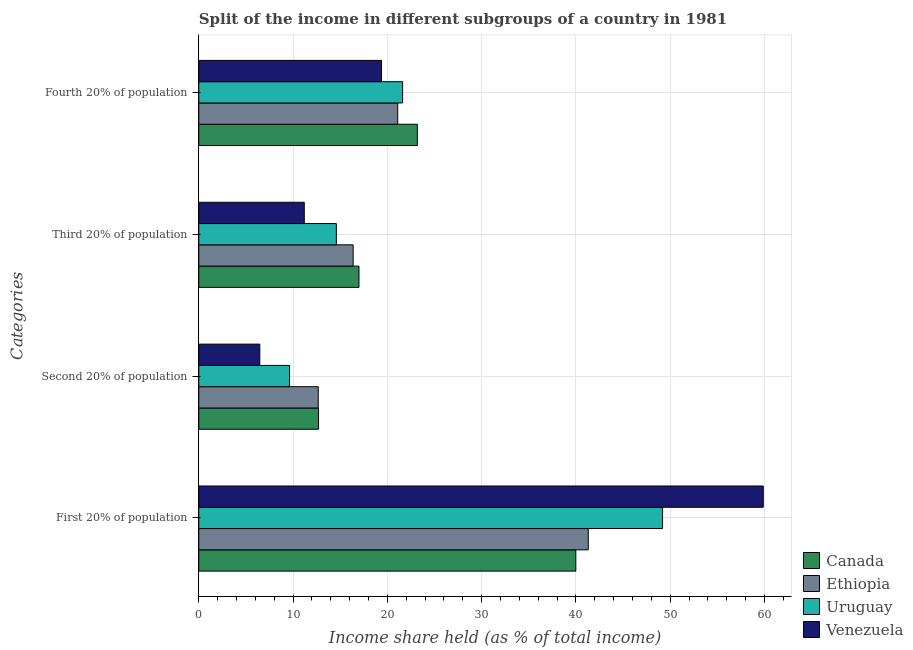How many groups of bars are there?
Ensure brevity in your answer.  4. How many bars are there on the 1st tick from the top?
Keep it short and to the point. 4. How many bars are there on the 2nd tick from the bottom?
Make the answer very short. 4. What is the label of the 3rd group of bars from the top?
Offer a very short reply. Second 20% of population. What is the share of the income held by second 20% of the population in Canada?
Provide a short and direct response. 12.7. Across all countries, what is the maximum share of the income held by third 20% of the population?
Your answer should be compact. 16.99. Across all countries, what is the minimum share of the income held by second 20% of the population?
Make the answer very short. 6.47. In which country was the share of the income held by third 20% of the population minimum?
Your response must be concise. Venezuela. What is the total share of the income held by second 20% of the population in the graph?
Ensure brevity in your answer.  41.47. What is the difference between the share of the income held by fourth 20% of the population in Ethiopia and that in Venezuela?
Provide a short and direct response. 1.72. What is the difference between the share of the income held by third 20% of the population in Uruguay and the share of the income held by first 20% of the population in Venezuela?
Keep it short and to the point. -45.28. What is the average share of the income held by fourth 20% of the population per country?
Give a very brief answer. 21.32. What is the difference between the share of the income held by first 20% of the population and share of the income held by second 20% of the population in Uruguay?
Make the answer very short. 39.56. What is the ratio of the share of the income held by third 20% of the population in Ethiopia to that in Canada?
Make the answer very short. 0.96. Is the share of the income held by first 20% of the population in Canada less than that in Venezuela?
Your response must be concise. Yes. Is the difference between the share of the income held by fourth 20% of the population in Venezuela and Uruguay greater than the difference between the share of the income held by second 20% of the population in Venezuela and Uruguay?
Provide a short and direct response. Yes. What is the difference between the highest and the second highest share of the income held by second 20% of the population?
Provide a succinct answer. 0.03. What is the difference between the highest and the lowest share of the income held by third 20% of the population?
Make the answer very short. 5.8. In how many countries, is the share of the income held by fourth 20% of the population greater than the average share of the income held by fourth 20% of the population taken over all countries?
Your answer should be very brief. 2. Is the sum of the share of the income held by fourth 20% of the population in Venezuela and Canada greater than the maximum share of the income held by first 20% of the population across all countries?
Keep it short and to the point. No. Is it the case that in every country, the sum of the share of the income held by third 20% of the population and share of the income held by second 20% of the population is greater than the sum of share of the income held by first 20% of the population and share of the income held by fourth 20% of the population?
Offer a terse response. Yes. What does the 2nd bar from the top in Second 20% of population represents?
Provide a succinct answer. Uruguay. What does the 3rd bar from the bottom in Fourth 20% of population represents?
Your response must be concise. Uruguay. How many bars are there?
Make the answer very short. 16. Are the values on the major ticks of X-axis written in scientific E-notation?
Offer a very short reply. No. Does the graph contain any zero values?
Make the answer very short. No. Does the graph contain grids?
Your answer should be compact. Yes. Where does the legend appear in the graph?
Keep it short and to the point. Bottom right. How many legend labels are there?
Your answer should be compact. 4. What is the title of the graph?
Provide a short and direct response. Split of the income in different subgroups of a country in 1981. Does "Turkmenistan" appear as one of the legend labels in the graph?
Give a very brief answer. No. What is the label or title of the X-axis?
Provide a short and direct response. Income share held (as % of total income). What is the label or title of the Y-axis?
Make the answer very short. Categories. What is the Income share held (as % of total income) of Canada in First 20% of population?
Make the answer very short. 39.99. What is the Income share held (as % of total income) in Ethiopia in First 20% of population?
Provide a short and direct response. 41.31. What is the Income share held (as % of total income) in Uruguay in First 20% of population?
Your response must be concise. 49.19. What is the Income share held (as % of total income) of Venezuela in First 20% of population?
Give a very brief answer. 59.87. What is the Income share held (as % of total income) in Canada in Second 20% of population?
Offer a very short reply. 12.7. What is the Income share held (as % of total income) in Ethiopia in Second 20% of population?
Offer a very short reply. 12.67. What is the Income share held (as % of total income) of Uruguay in Second 20% of population?
Provide a short and direct response. 9.63. What is the Income share held (as % of total income) in Venezuela in Second 20% of population?
Offer a terse response. 6.47. What is the Income share held (as % of total income) in Canada in Third 20% of population?
Keep it short and to the point. 16.99. What is the Income share held (as % of total income) of Ethiopia in Third 20% of population?
Offer a terse response. 16.37. What is the Income share held (as % of total income) of Uruguay in Third 20% of population?
Provide a short and direct response. 14.59. What is the Income share held (as % of total income) of Venezuela in Third 20% of population?
Your answer should be very brief. 11.19. What is the Income share held (as % of total income) of Canada in Fourth 20% of population?
Keep it short and to the point. 23.18. What is the Income share held (as % of total income) of Ethiopia in Fourth 20% of population?
Provide a succinct answer. 21.1. What is the Income share held (as % of total income) in Uruguay in Fourth 20% of population?
Keep it short and to the point. 21.62. What is the Income share held (as % of total income) of Venezuela in Fourth 20% of population?
Provide a succinct answer. 19.38. Across all Categories, what is the maximum Income share held (as % of total income) of Canada?
Give a very brief answer. 39.99. Across all Categories, what is the maximum Income share held (as % of total income) in Ethiopia?
Provide a succinct answer. 41.31. Across all Categories, what is the maximum Income share held (as % of total income) of Uruguay?
Provide a succinct answer. 49.19. Across all Categories, what is the maximum Income share held (as % of total income) in Venezuela?
Your answer should be compact. 59.87. Across all Categories, what is the minimum Income share held (as % of total income) in Ethiopia?
Your answer should be compact. 12.67. Across all Categories, what is the minimum Income share held (as % of total income) of Uruguay?
Your answer should be very brief. 9.63. Across all Categories, what is the minimum Income share held (as % of total income) of Venezuela?
Provide a short and direct response. 6.47. What is the total Income share held (as % of total income) in Canada in the graph?
Provide a succinct answer. 92.86. What is the total Income share held (as % of total income) of Ethiopia in the graph?
Your answer should be very brief. 91.45. What is the total Income share held (as % of total income) of Uruguay in the graph?
Provide a succinct answer. 95.03. What is the total Income share held (as % of total income) in Venezuela in the graph?
Your answer should be compact. 96.91. What is the difference between the Income share held (as % of total income) in Canada in First 20% of population and that in Second 20% of population?
Your response must be concise. 27.29. What is the difference between the Income share held (as % of total income) in Ethiopia in First 20% of population and that in Second 20% of population?
Provide a short and direct response. 28.64. What is the difference between the Income share held (as % of total income) of Uruguay in First 20% of population and that in Second 20% of population?
Provide a succinct answer. 39.56. What is the difference between the Income share held (as % of total income) of Venezuela in First 20% of population and that in Second 20% of population?
Give a very brief answer. 53.4. What is the difference between the Income share held (as % of total income) in Canada in First 20% of population and that in Third 20% of population?
Provide a succinct answer. 23. What is the difference between the Income share held (as % of total income) in Ethiopia in First 20% of population and that in Third 20% of population?
Provide a succinct answer. 24.94. What is the difference between the Income share held (as % of total income) in Uruguay in First 20% of population and that in Third 20% of population?
Your answer should be very brief. 34.6. What is the difference between the Income share held (as % of total income) of Venezuela in First 20% of population and that in Third 20% of population?
Your response must be concise. 48.68. What is the difference between the Income share held (as % of total income) of Canada in First 20% of population and that in Fourth 20% of population?
Your response must be concise. 16.81. What is the difference between the Income share held (as % of total income) of Ethiopia in First 20% of population and that in Fourth 20% of population?
Offer a terse response. 20.21. What is the difference between the Income share held (as % of total income) in Uruguay in First 20% of population and that in Fourth 20% of population?
Provide a succinct answer. 27.57. What is the difference between the Income share held (as % of total income) in Venezuela in First 20% of population and that in Fourth 20% of population?
Provide a succinct answer. 40.49. What is the difference between the Income share held (as % of total income) in Canada in Second 20% of population and that in Third 20% of population?
Your answer should be very brief. -4.29. What is the difference between the Income share held (as % of total income) in Uruguay in Second 20% of population and that in Third 20% of population?
Offer a terse response. -4.96. What is the difference between the Income share held (as % of total income) in Venezuela in Second 20% of population and that in Third 20% of population?
Your response must be concise. -4.72. What is the difference between the Income share held (as % of total income) of Canada in Second 20% of population and that in Fourth 20% of population?
Give a very brief answer. -10.48. What is the difference between the Income share held (as % of total income) in Ethiopia in Second 20% of population and that in Fourth 20% of population?
Provide a succinct answer. -8.43. What is the difference between the Income share held (as % of total income) in Uruguay in Second 20% of population and that in Fourth 20% of population?
Make the answer very short. -11.99. What is the difference between the Income share held (as % of total income) of Venezuela in Second 20% of population and that in Fourth 20% of population?
Give a very brief answer. -12.91. What is the difference between the Income share held (as % of total income) of Canada in Third 20% of population and that in Fourth 20% of population?
Provide a short and direct response. -6.19. What is the difference between the Income share held (as % of total income) in Ethiopia in Third 20% of population and that in Fourth 20% of population?
Make the answer very short. -4.73. What is the difference between the Income share held (as % of total income) of Uruguay in Third 20% of population and that in Fourth 20% of population?
Offer a very short reply. -7.03. What is the difference between the Income share held (as % of total income) in Venezuela in Third 20% of population and that in Fourth 20% of population?
Your answer should be compact. -8.19. What is the difference between the Income share held (as % of total income) in Canada in First 20% of population and the Income share held (as % of total income) in Ethiopia in Second 20% of population?
Give a very brief answer. 27.32. What is the difference between the Income share held (as % of total income) in Canada in First 20% of population and the Income share held (as % of total income) in Uruguay in Second 20% of population?
Make the answer very short. 30.36. What is the difference between the Income share held (as % of total income) of Canada in First 20% of population and the Income share held (as % of total income) of Venezuela in Second 20% of population?
Offer a very short reply. 33.52. What is the difference between the Income share held (as % of total income) of Ethiopia in First 20% of population and the Income share held (as % of total income) of Uruguay in Second 20% of population?
Offer a very short reply. 31.68. What is the difference between the Income share held (as % of total income) of Ethiopia in First 20% of population and the Income share held (as % of total income) of Venezuela in Second 20% of population?
Offer a very short reply. 34.84. What is the difference between the Income share held (as % of total income) in Uruguay in First 20% of population and the Income share held (as % of total income) in Venezuela in Second 20% of population?
Your response must be concise. 42.72. What is the difference between the Income share held (as % of total income) of Canada in First 20% of population and the Income share held (as % of total income) of Ethiopia in Third 20% of population?
Your response must be concise. 23.62. What is the difference between the Income share held (as % of total income) of Canada in First 20% of population and the Income share held (as % of total income) of Uruguay in Third 20% of population?
Offer a terse response. 25.4. What is the difference between the Income share held (as % of total income) of Canada in First 20% of population and the Income share held (as % of total income) of Venezuela in Third 20% of population?
Offer a very short reply. 28.8. What is the difference between the Income share held (as % of total income) of Ethiopia in First 20% of population and the Income share held (as % of total income) of Uruguay in Third 20% of population?
Provide a short and direct response. 26.72. What is the difference between the Income share held (as % of total income) in Ethiopia in First 20% of population and the Income share held (as % of total income) in Venezuela in Third 20% of population?
Your answer should be very brief. 30.12. What is the difference between the Income share held (as % of total income) of Uruguay in First 20% of population and the Income share held (as % of total income) of Venezuela in Third 20% of population?
Your response must be concise. 38. What is the difference between the Income share held (as % of total income) in Canada in First 20% of population and the Income share held (as % of total income) in Ethiopia in Fourth 20% of population?
Keep it short and to the point. 18.89. What is the difference between the Income share held (as % of total income) of Canada in First 20% of population and the Income share held (as % of total income) of Uruguay in Fourth 20% of population?
Your answer should be very brief. 18.37. What is the difference between the Income share held (as % of total income) in Canada in First 20% of population and the Income share held (as % of total income) in Venezuela in Fourth 20% of population?
Provide a short and direct response. 20.61. What is the difference between the Income share held (as % of total income) of Ethiopia in First 20% of population and the Income share held (as % of total income) of Uruguay in Fourth 20% of population?
Provide a short and direct response. 19.69. What is the difference between the Income share held (as % of total income) in Ethiopia in First 20% of population and the Income share held (as % of total income) in Venezuela in Fourth 20% of population?
Provide a succinct answer. 21.93. What is the difference between the Income share held (as % of total income) of Uruguay in First 20% of population and the Income share held (as % of total income) of Venezuela in Fourth 20% of population?
Provide a succinct answer. 29.81. What is the difference between the Income share held (as % of total income) of Canada in Second 20% of population and the Income share held (as % of total income) of Ethiopia in Third 20% of population?
Offer a very short reply. -3.67. What is the difference between the Income share held (as % of total income) of Canada in Second 20% of population and the Income share held (as % of total income) of Uruguay in Third 20% of population?
Keep it short and to the point. -1.89. What is the difference between the Income share held (as % of total income) of Canada in Second 20% of population and the Income share held (as % of total income) of Venezuela in Third 20% of population?
Your answer should be compact. 1.51. What is the difference between the Income share held (as % of total income) in Ethiopia in Second 20% of population and the Income share held (as % of total income) in Uruguay in Third 20% of population?
Offer a terse response. -1.92. What is the difference between the Income share held (as % of total income) of Ethiopia in Second 20% of population and the Income share held (as % of total income) of Venezuela in Third 20% of population?
Provide a short and direct response. 1.48. What is the difference between the Income share held (as % of total income) of Uruguay in Second 20% of population and the Income share held (as % of total income) of Venezuela in Third 20% of population?
Your answer should be very brief. -1.56. What is the difference between the Income share held (as % of total income) in Canada in Second 20% of population and the Income share held (as % of total income) in Ethiopia in Fourth 20% of population?
Offer a terse response. -8.4. What is the difference between the Income share held (as % of total income) of Canada in Second 20% of population and the Income share held (as % of total income) of Uruguay in Fourth 20% of population?
Your response must be concise. -8.92. What is the difference between the Income share held (as % of total income) in Canada in Second 20% of population and the Income share held (as % of total income) in Venezuela in Fourth 20% of population?
Offer a terse response. -6.68. What is the difference between the Income share held (as % of total income) of Ethiopia in Second 20% of population and the Income share held (as % of total income) of Uruguay in Fourth 20% of population?
Give a very brief answer. -8.95. What is the difference between the Income share held (as % of total income) in Ethiopia in Second 20% of population and the Income share held (as % of total income) in Venezuela in Fourth 20% of population?
Ensure brevity in your answer.  -6.71. What is the difference between the Income share held (as % of total income) of Uruguay in Second 20% of population and the Income share held (as % of total income) of Venezuela in Fourth 20% of population?
Your response must be concise. -9.75. What is the difference between the Income share held (as % of total income) of Canada in Third 20% of population and the Income share held (as % of total income) of Ethiopia in Fourth 20% of population?
Your answer should be very brief. -4.11. What is the difference between the Income share held (as % of total income) in Canada in Third 20% of population and the Income share held (as % of total income) in Uruguay in Fourth 20% of population?
Provide a succinct answer. -4.63. What is the difference between the Income share held (as % of total income) of Canada in Third 20% of population and the Income share held (as % of total income) of Venezuela in Fourth 20% of population?
Provide a short and direct response. -2.39. What is the difference between the Income share held (as % of total income) in Ethiopia in Third 20% of population and the Income share held (as % of total income) in Uruguay in Fourth 20% of population?
Your response must be concise. -5.25. What is the difference between the Income share held (as % of total income) of Ethiopia in Third 20% of population and the Income share held (as % of total income) of Venezuela in Fourth 20% of population?
Keep it short and to the point. -3.01. What is the difference between the Income share held (as % of total income) in Uruguay in Third 20% of population and the Income share held (as % of total income) in Venezuela in Fourth 20% of population?
Make the answer very short. -4.79. What is the average Income share held (as % of total income) in Canada per Categories?
Your response must be concise. 23.21. What is the average Income share held (as % of total income) in Ethiopia per Categories?
Offer a very short reply. 22.86. What is the average Income share held (as % of total income) of Uruguay per Categories?
Offer a very short reply. 23.76. What is the average Income share held (as % of total income) in Venezuela per Categories?
Make the answer very short. 24.23. What is the difference between the Income share held (as % of total income) of Canada and Income share held (as % of total income) of Ethiopia in First 20% of population?
Offer a terse response. -1.32. What is the difference between the Income share held (as % of total income) of Canada and Income share held (as % of total income) of Venezuela in First 20% of population?
Ensure brevity in your answer.  -19.88. What is the difference between the Income share held (as % of total income) in Ethiopia and Income share held (as % of total income) in Uruguay in First 20% of population?
Provide a succinct answer. -7.88. What is the difference between the Income share held (as % of total income) of Ethiopia and Income share held (as % of total income) of Venezuela in First 20% of population?
Provide a succinct answer. -18.56. What is the difference between the Income share held (as % of total income) in Uruguay and Income share held (as % of total income) in Venezuela in First 20% of population?
Offer a very short reply. -10.68. What is the difference between the Income share held (as % of total income) in Canada and Income share held (as % of total income) in Ethiopia in Second 20% of population?
Your answer should be compact. 0.03. What is the difference between the Income share held (as % of total income) in Canada and Income share held (as % of total income) in Uruguay in Second 20% of population?
Provide a succinct answer. 3.07. What is the difference between the Income share held (as % of total income) in Canada and Income share held (as % of total income) in Venezuela in Second 20% of population?
Offer a terse response. 6.23. What is the difference between the Income share held (as % of total income) in Ethiopia and Income share held (as % of total income) in Uruguay in Second 20% of population?
Offer a very short reply. 3.04. What is the difference between the Income share held (as % of total income) in Uruguay and Income share held (as % of total income) in Venezuela in Second 20% of population?
Ensure brevity in your answer.  3.16. What is the difference between the Income share held (as % of total income) in Canada and Income share held (as % of total income) in Ethiopia in Third 20% of population?
Offer a terse response. 0.62. What is the difference between the Income share held (as % of total income) of Canada and Income share held (as % of total income) of Venezuela in Third 20% of population?
Offer a very short reply. 5.8. What is the difference between the Income share held (as % of total income) of Ethiopia and Income share held (as % of total income) of Uruguay in Third 20% of population?
Your answer should be very brief. 1.78. What is the difference between the Income share held (as % of total income) of Ethiopia and Income share held (as % of total income) of Venezuela in Third 20% of population?
Your response must be concise. 5.18. What is the difference between the Income share held (as % of total income) in Canada and Income share held (as % of total income) in Ethiopia in Fourth 20% of population?
Your answer should be very brief. 2.08. What is the difference between the Income share held (as % of total income) in Canada and Income share held (as % of total income) in Uruguay in Fourth 20% of population?
Offer a very short reply. 1.56. What is the difference between the Income share held (as % of total income) in Ethiopia and Income share held (as % of total income) in Uruguay in Fourth 20% of population?
Make the answer very short. -0.52. What is the difference between the Income share held (as % of total income) of Ethiopia and Income share held (as % of total income) of Venezuela in Fourth 20% of population?
Your answer should be very brief. 1.72. What is the difference between the Income share held (as % of total income) in Uruguay and Income share held (as % of total income) in Venezuela in Fourth 20% of population?
Offer a very short reply. 2.24. What is the ratio of the Income share held (as % of total income) in Canada in First 20% of population to that in Second 20% of population?
Make the answer very short. 3.15. What is the ratio of the Income share held (as % of total income) of Ethiopia in First 20% of population to that in Second 20% of population?
Ensure brevity in your answer.  3.26. What is the ratio of the Income share held (as % of total income) in Uruguay in First 20% of population to that in Second 20% of population?
Provide a succinct answer. 5.11. What is the ratio of the Income share held (as % of total income) of Venezuela in First 20% of population to that in Second 20% of population?
Your response must be concise. 9.25. What is the ratio of the Income share held (as % of total income) in Canada in First 20% of population to that in Third 20% of population?
Your answer should be compact. 2.35. What is the ratio of the Income share held (as % of total income) of Ethiopia in First 20% of population to that in Third 20% of population?
Provide a succinct answer. 2.52. What is the ratio of the Income share held (as % of total income) of Uruguay in First 20% of population to that in Third 20% of population?
Provide a succinct answer. 3.37. What is the ratio of the Income share held (as % of total income) of Venezuela in First 20% of population to that in Third 20% of population?
Make the answer very short. 5.35. What is the ratio of the Income share held (as % of total income) of Canada in First 20% of population to that in Fourth 20% of population?
Your answer should be very brief. 1.73. What is the ratio of the Income share held (as % of total income) of Ethiopia in First 20% of population to that in Fourth 20% of population?
Provide a short and direct response. 1.96. What is the ratio of the Income share held (as % of total income) in Uruguay in First 20% of population to that in Fourth 20% of population?
Make the answer very short. 2.28. What is the ratio of the Income share held (as % of total income) of Venezuela in First 20% of population to that in Fourth 20% of population?
Provide a short and direct response. 3.09. What is the ratio of the Income share held (as % of total income) in Canada in Second 20% of population to that in Third 20% of population?
Offer a very short reply. 0.75. What is the ratio of the Income share held (as % of total income) in Ethiopia in Second 20% of population to that in Third 20% of population?
Your answer should be very brief. 0.77. What is the ratio of the Income share held (as % of total income) of Uruguay in Second 20% of population to that in Third 20% of population?
Your response must be concise. 0.66. What is the ratio of the Income share held (as % of total income) of Venezuela in Second 20% of population to that in Third 20% of population?
Keep it short and to the point. 0.58. What is the ratio of the Income share held (as % of total income) of Canada in Second 20% of population to that in Fourth 20% of population?
Provide a short and direct response. 0.55. What is the ratio of the Income share held (as % of total income) of Ethiopia in Second 20% of population to that in Fourth 20% of population?
Offer a very short reply. 0.6. What is the ratio of the Income share held (as % of total income) of Uruguay in Second 20% of population to that in Fourth 20% of population?
Offer a very short reply. 0.45. What is the ratio of the Income share held (as % of total income) of Venezuela in Second 20% of population to that in Fourth 20% of population?
Offer a terse response. 0.33. What is the ratio of the Income share held (as % of total income) of Canada in Third 20% of population to that in Fourth 20% of population?
Make the answer very short. 0.73. What is the ratio of the Income share held (as % of total income) in Ethiopia in Third 20% of population to that in Fourth 20% of population?
Your answer should be very brief. 0.78. What is the ratio of the Income share held (as % of total income) in Uruguay in Third 20% of population to that in Fourth 20% of population?
Your answer should be very brief. 0.67. What is the ratio of the Income share held (as % of total income) in Venezuela in Third 20% of population to that in Fourth 20% of population?
Offer a very short reply. 0.58. What is the difference between the highest and the second highest Income share held (as % of total income) in Canada?
Keep it short and to the point. 16.81. What is the difference between the highest and the second highest Income share held (as % of total income) of Ethiopia?
Your answer should be very brief. 20.21. What is the difference between the highest and the second highest Income share held (as % of total income) of Uruguay?
Your response must be concise. 27.57. What is the difference between the highest and the second highest Income share held (as % of total income) in Venezuela?
Keep it short and to the point. 40.49. What is the difference between the highest and the lowest Income share held (as % of total income) of Canada?
Make the answer very short. 27.29. What is the difference between the highest and the lowest Income share held (as % of total income) in Ethiopia?
Keep it short and to the point. 28.64. What is the difference between the highest and the lowest Income share held (as % of total income) in Uruguay?
Your answer should be very brief. 39.56. What is the difference between the highest and the lowest Income share held (as % of total income) in Venezuela?
Offer a terse response. 53.4. 